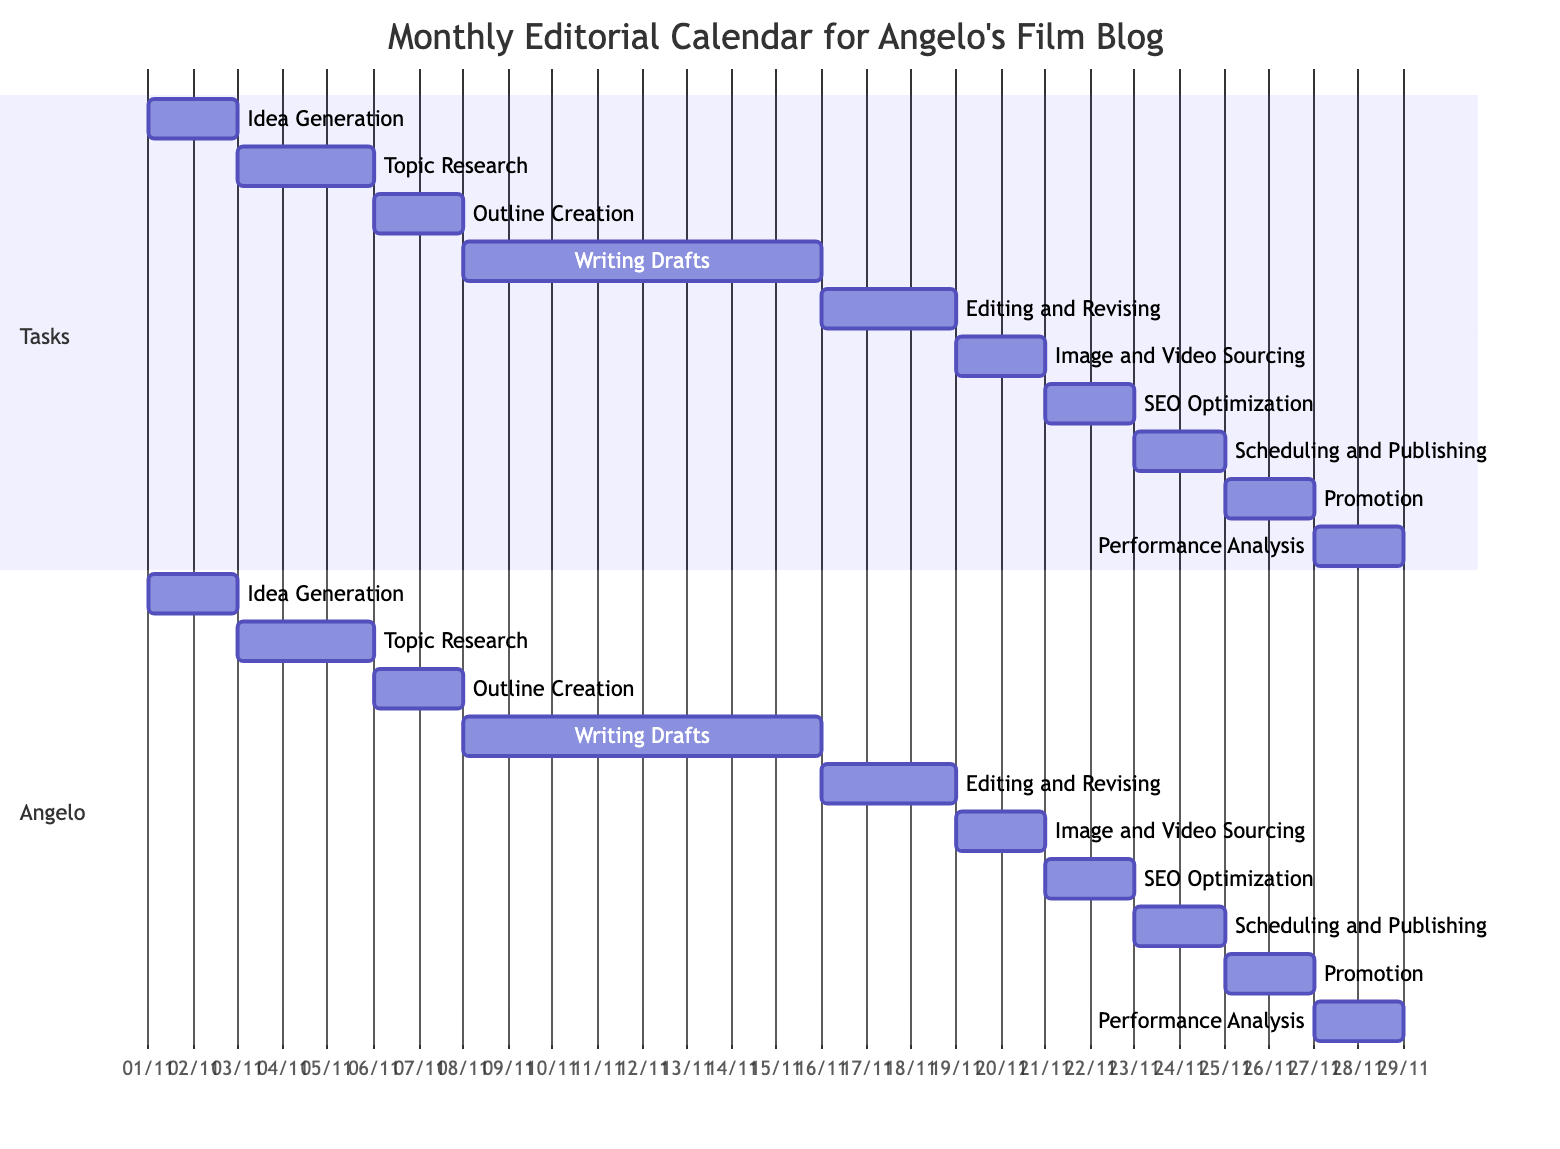What task starts on November 1, 2023? Looking at the diagram, we see the task "Idea Generation" is the first task listed and it begins on November 1, 2023.
Answer: Idea Generation How long does "Writing Drafts" take? The task "Writing Drafts" starts on November 8, 2023, and ends on November 15, 2023. Counting the days, it spans a total of 8 days.
Answer: 8 days Which task follows "Editing and Revising"? In the Gantt chart, "Image and Video Sourcing" is indicated to follow "Editing and Revising" based on the order shown in the timeline.
Answer: Image and Video Sourcing On what date is "SEO Optimization" scheduled to start? By referencing the timeline, "SEO Optimization" is scheduled to begin on November 21, 2023, immediately after "Image and Video Sourcing."
Answer: November 21, 2023 What is the total number of tasks shown in the Gantt chart? Counting each distinct task in the Gantt chart, there are 10 tasks listed concerning blog posts for the month.
Answer: 10 tasks Which task has the longest duration? Looking at all tasks, "Writing Drafts" lasts 8 days, while the others have shorter durations. Therefore, it has the longest duration among all tasks.
Answer: Writing Drafts What is the end date for "Performance Analysis"? The task "Performance Analysis" starts on November 27, 2023, and given it occupies 2 days, it concludes on November 28, 2023.
Answer: November 28, 2023 How many days are allocated for "Promotion"? The task "Promotion" is shown to take place over a period of 2 days, from November 25 to November 26, 2023.
Answer: 2 days Which task requires research on selected topics? Referring to the task descriptions, "Topic Research" explicitly mentions conducting research on selected topics as part of its description.
Answer: Topic Research 